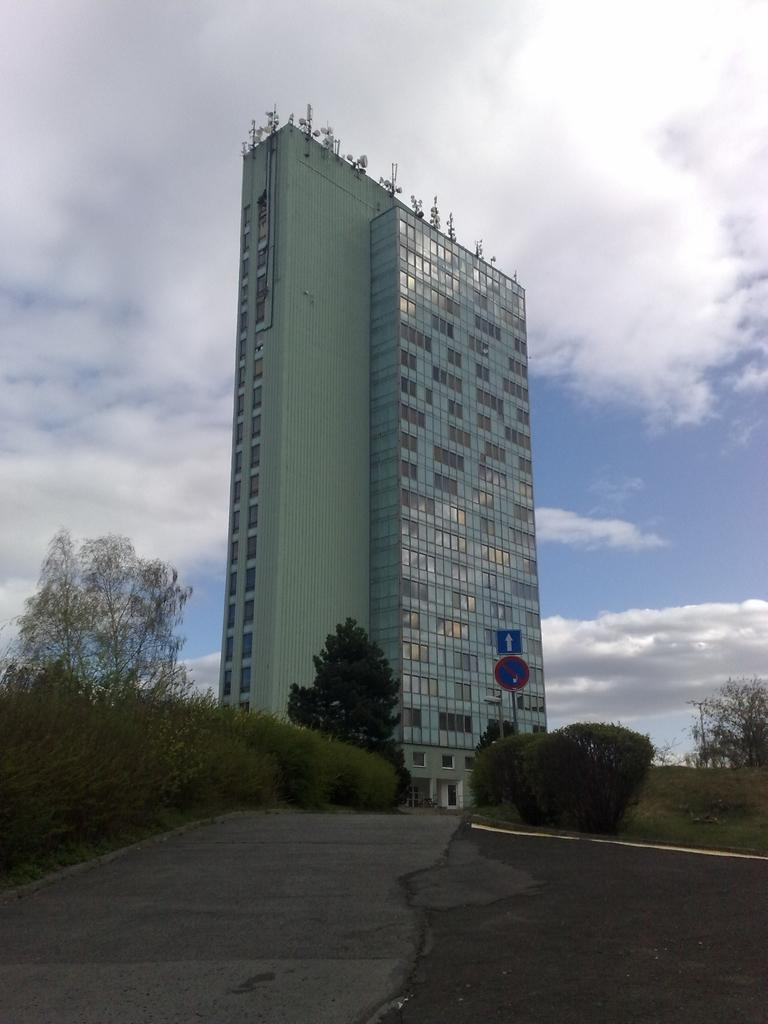What type of structure is visible in the picture? There is a building in the picture. What feature can be observed on the building? The building has glass windows. What type of vegetation is present in the picture? There are plants and trees in the picture. What is the condition of the sky in the picture? The sky is clear in the picture. What type of jelly can be seen on the building's windows in the image? There is no jelly present on the building's windows in the image. What is the chance of a plant growing on the building in the image? The image does not provide information about the likelihood of a plant growing on the building, as it only shows the building's current state. 